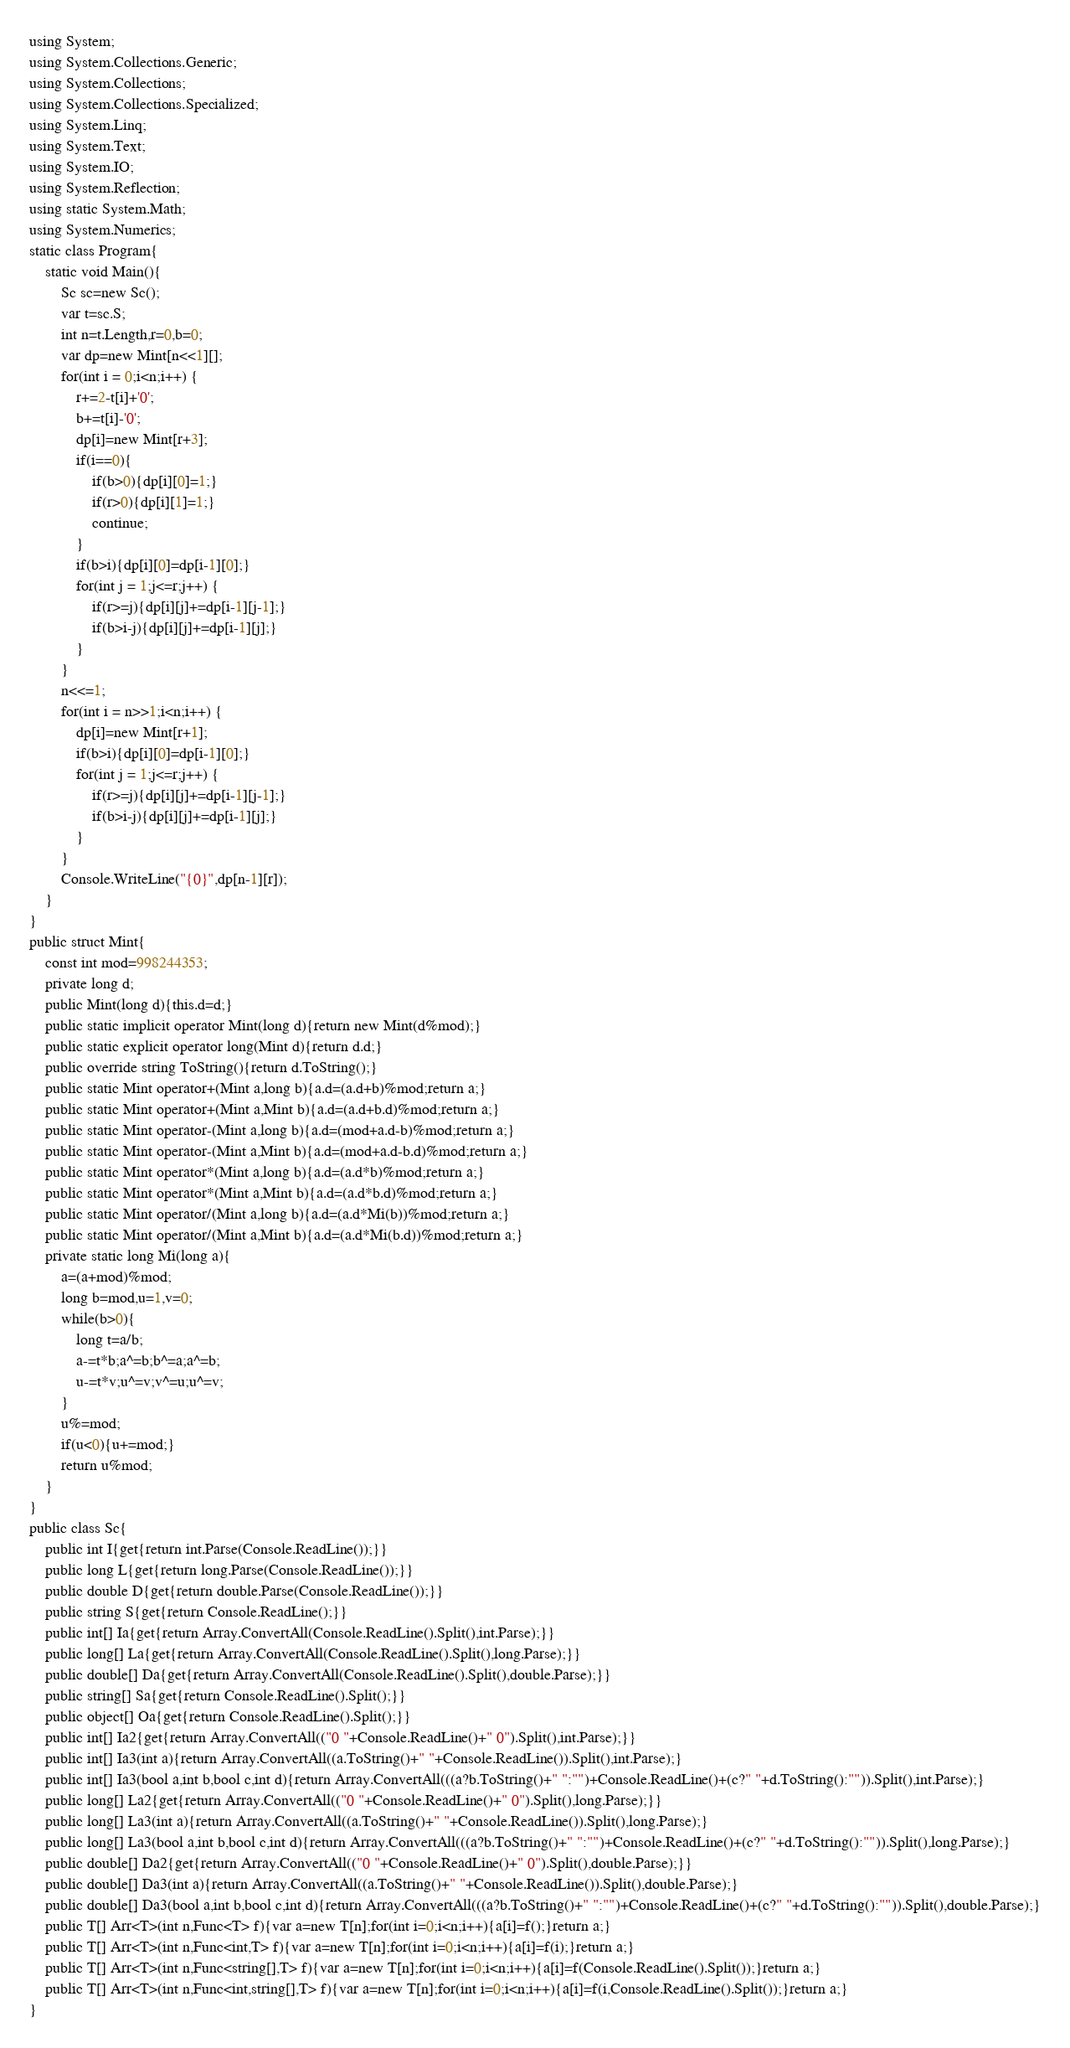<code> <loc_0><loc_0><loc_500><loc_500><_C#_>using System;
using System.Collections.Generic;
using System.Collections;
using System.Collections.Specialized;
using System.Linq;
using System.Text;
using System.IO;
using System.Reflection;
using static System.Math;
using System.Numerics;
static class Program{
	static void Main(){
		Sc sc=new Sc();
		var t=sc.S;
		int n=t.Length,r=0,b=0;
		var dp=new Mint[n<<1][];
		for(int i = 0;i<n;i++) {
			r+=2-t[i]+'0';
			b+=t[i]-'0';
			dp[i]=new Mint[r+3];
			if(i==0){
				if(b>0){dp[i][0]=1;}
				if(r>0){dp[i][1]=1;}
				continue;
			}
			if(b>i){dp[i][0]=dp[i-1][0];}
			for(int j = 1;j<=r;j++) {
				if(r>=j){dp[i][j]+=dp[i-1][j-1];}
				if(b>i-j){dp[i][j]+=dp[i-1][j];}
			}
		}
		n<<=1;
		for(int i = n>>1;i<n;i++) {
			dp[i]=new Mint[r+1];
			if(b>i){dp[i][0]=dp[i-1][0];}
			for(int j = 1;j<=r;j++) {
				if(r>=j){dp[i][j]+=dp[i-1][j-1];}
				if(b>i-j){dp[i][j]+=dp[i-1][j];}
			}
		}
		Console.WriteLine("{0}",dp[n-1][r]);
	}
}
public struct Mint{
	const int mod=998244353;
	private long d;
	public Mint(long d){this.d=d;}
	public static implicit operator Mint(long d){return new Mint(d%mod);}
	public static explicit operator long(Mint d){return d.d;}
	public override string ToString(){return d.ToString();}
	public static Mint operator+(Mint a,long b){a.d=(a.d+b)%mod;return a;}
	public static Mint operator+(Mint a,Mint b){a.d=(a.d+b.d)%mod;return a;}
	public static Mint operator-(Mint a,long b){a.d=(mod+a.d-b)%mod;return a;}
	public static Mint operator-(Mint a,Mint b){a.d=(mod+a.d-b.d)%mod;return a;}
	public static Mint operator*(Mint a,long b){a.d=(a.d*b)%mod;return a;}
	public static Mint operator*(Mint a,Mint b){a.d=(a.d*b.d)%mod;return a;}
	public static Mint operator/(Mint a,long b){a.d=(a.d*Mi(b))%mod;return a;}
	public static Mint operator/(Mint a,Mint b){a.d=(a.d*Mi(b.d))%mod;return a;}
	private static long Mi(long a){
		a=(a+mod)%mod;
		long b=mod,u=1,v=0;
		while(b>0){
			long t=a/b;
			a-=t*b;a^=b;b^=a;a^=b;
			u-=t*v;u^=v;v^=u;u^=v;
		}
		u%=mod;
		if(u<0){u+=mod;}
		return u%mod;
	}
}
public class Sc{
	public int I{get{return int.Parse(Console.ReadLine());}}
	public long L{get{return long.Parse(Console.ReadLine());}}
	public double D{get{return double.Parse(Console.ReadLine());}}
	public string S{get{return Console.ReadLine();}}
	public int[] Ia{get{return Array.ConvertAll(Console.ReadLine().Split(),int.Parse);}}
	public long[] La{get{return Array.ConvertAll(Console.ReadLine().Split(),long.Parse);}}
	public double[] Da{get{return Array.ConvertAll(Console.ReadLine().Split(),double.Parse);}}
	public string[] Sa{get{return Console.ReadLine().Split();}}
	public object[] Oa{get{return Console.ReadLine().Split();}}
	public int[] Ia2{get{return Array.ConvertAll(("0 "+Console.ReadLine()+" 0").Split(),int.Parse);}}
	public int[] Ia3(int a){return Array.ConvertAll((a.ToString()+" "+Console.ReadLine()).Split(),int.Parse);}
	public int[] Ia3(bool a,int b,bool c,int d){return Array.ConvertAll(((a?b.ToString()+" ":"")+Console.ReadLine()+(c?" "+d.ToString():"")).Split(),int.Parse);}
	public long[] La2{get{return Array.ConvertAll(("0 "+Console.ReadLine()+" 0").Split(),long.Parse);}}
	public long[] La3(int a){return Array.ConvertAll((a.ToString()+" "+Console.ReadLine()).Split(),long.Parse);}
	public long[] La3(bool a,int b,bool c,int d){return Array.ConvertAll(((a?b.ToString()+" ":"")+Console.ReadLine()+(c?" "+d.ToString():"")).Split(),long.Parse);}
	public double[] Da2{get{return Array.ConvertAll(("0 "+Console.ReadLine()+" 0").Split(),double.Parse);}}
	public double[] Da3(int a){return Array.ConvertAll((a.ToString()+" "+Console.ReadLine()).Split(),double.Parse);}
	public double[] Da3(bool a,int b,bool c,int d){return Array.ConvertAll(((a?b.ToString()+" ":"")+Console.ReadLine()+(c?" "+d.ToString():"")).Split(),double.Parse);}
	public T[] Arr<T>(int n,Func<T> f){var a=new T[n];for(int i=0;i<n;i++){a[i]=f();}return a;}
	public T[] Arr<T>(int n,Func<int,T> f){var a=new T[n];for(int i=0;i<n;i++){a[i]=f(i);}return a;}
	public T[] Arr<T>(int n,Func<string[],T> f){var a=new T[n];for(int i=0;i<n;i++){a[i]=f(Console.ReadLine().Split());}return a;}
	public T[] Arr<T>(int n,Func<int,string[],T> f){var a=new T[n];for(int i=0;i<n;i++){a[i]=f(i,Console.ReadLine().Split());}return a;}
}</code> 